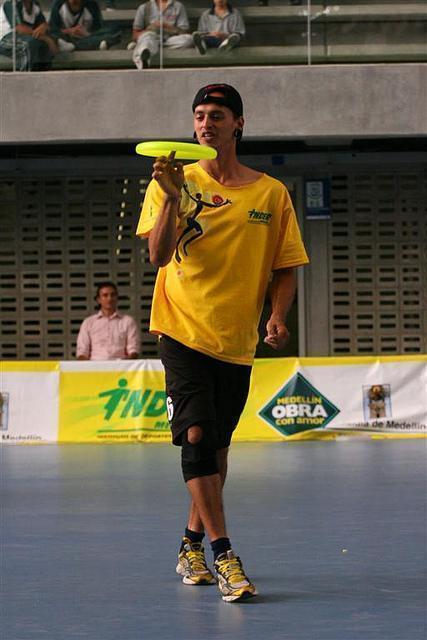The dominant color on the shirt is the same color as what food item?
Indicate the correct response by choosing from the four available options to answer the question.
Options: Ketchup, mustard, salt, relish. Mustard. 